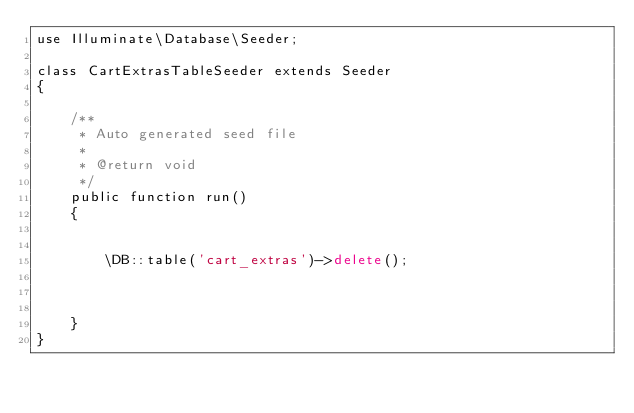Convert code to text. <code><loc_0><loc_0><loc_500><loc_500><_PHP_>use Illuminate\Database\Seeder;

class CartExtrasTableSeeder extends Seeder
{

    /**
     * Auto generated seed file
     *
     * @return void
     */
    public function run()
    {
        

        \DB::table('cart_extras')->delete();
        
        
        
    }
}</code> 